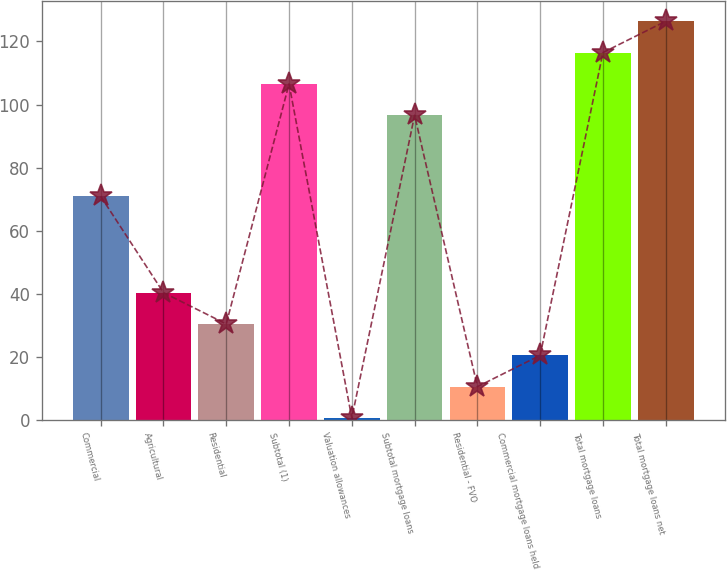<chart> <loc_0><loc_0><loc_500><loc_500><bar_chart><fcel>Commercial<fcel>Agricultural<fcel>Residential<fcel>Subtotal (1)<fcel>Valuation allowances<fcel>Subtotal mortgage loans<fcel>Residential - FVO<fcel>Commercial mortgage loans held<fcel>Total mortgage loans<fcel>Total mortgage loans net<nl><fcel>70.9<fcel>40.36<fcel>30.42<fcel>106.54<fcel>0.6<fcel>96.6<fcel>10.54<fcel>20.48<fcel>116.48<fcel>126.42<nl></chart> 